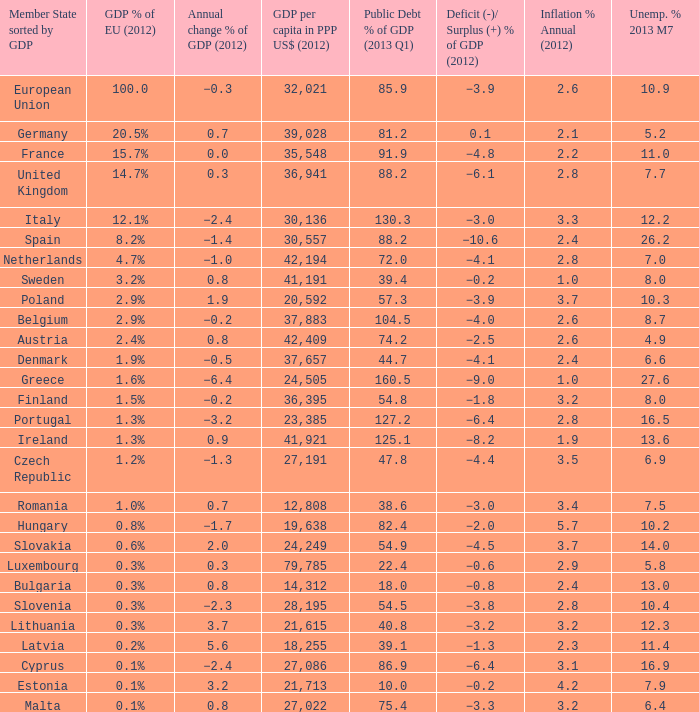What is the average public debt % of GDP in 2013 Q1 of the country with a member slate sorted by GDP of Czech Republic and a GDP per capita in PPP US dollars in 2012 greater than 27,191? None. 